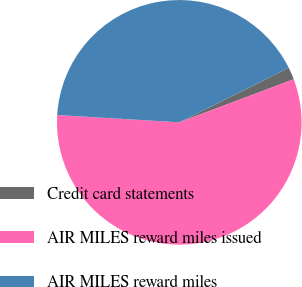<chart> <loc_0><loc_0><loc_500><loc_500><pie_chart><fcel>Credit card statements<fcel>AIR MILES reward miles issued<fcel>AIR MILES reward miles<nl><fcel>1.63%<fcel>56.68%<fcel>41.69%<nl></chart> 